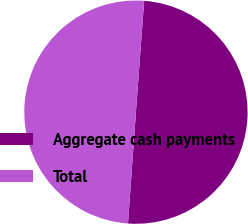<chart> <loc_0><loc_0><loc_500><loc_500><pie_chart><fcel>Aggregate cash payments<fcel>Total<nl><fcel>49.96%<fcel>50.04%<nl></chart> 